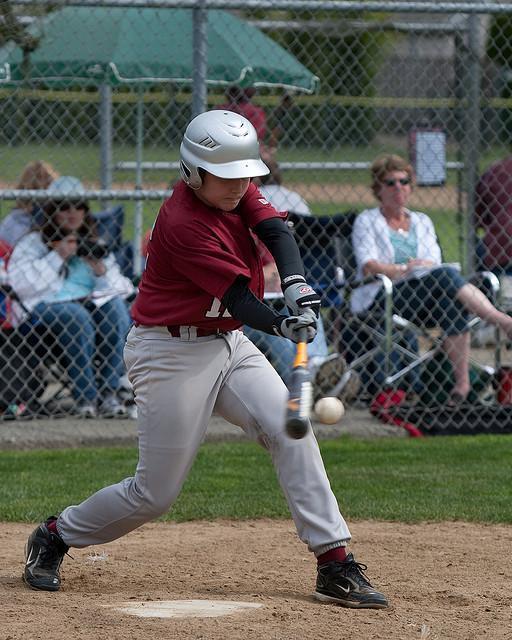How many shin pads does he have?
Give a very brief answer. 0. How many chairs can you see?
Give a very brief answer. 2. How many people can be seen?
Give a very brief answer. 5. 